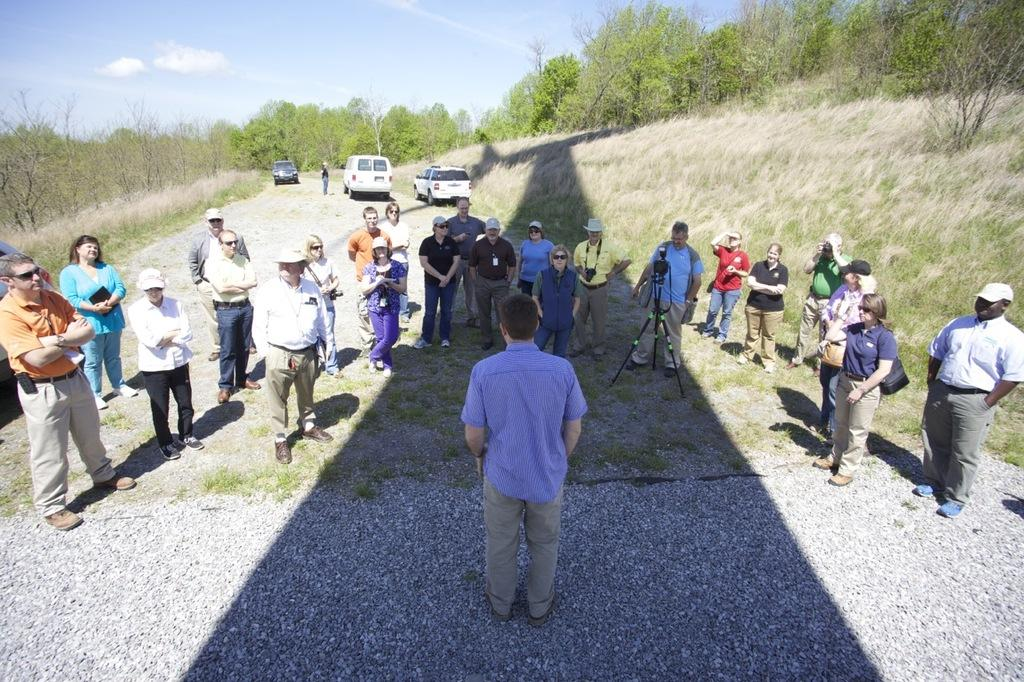Who or what can be seen in the image? There are people in the image. What else is present in the image besides people? There are vehicles, dry grass, trees, and the sky visible in the image. What type of brush is being used to paint the trees in the image? There is no brush or painting activity present in the image; it features people, vehicles, dry grass, trees, and the sky. 